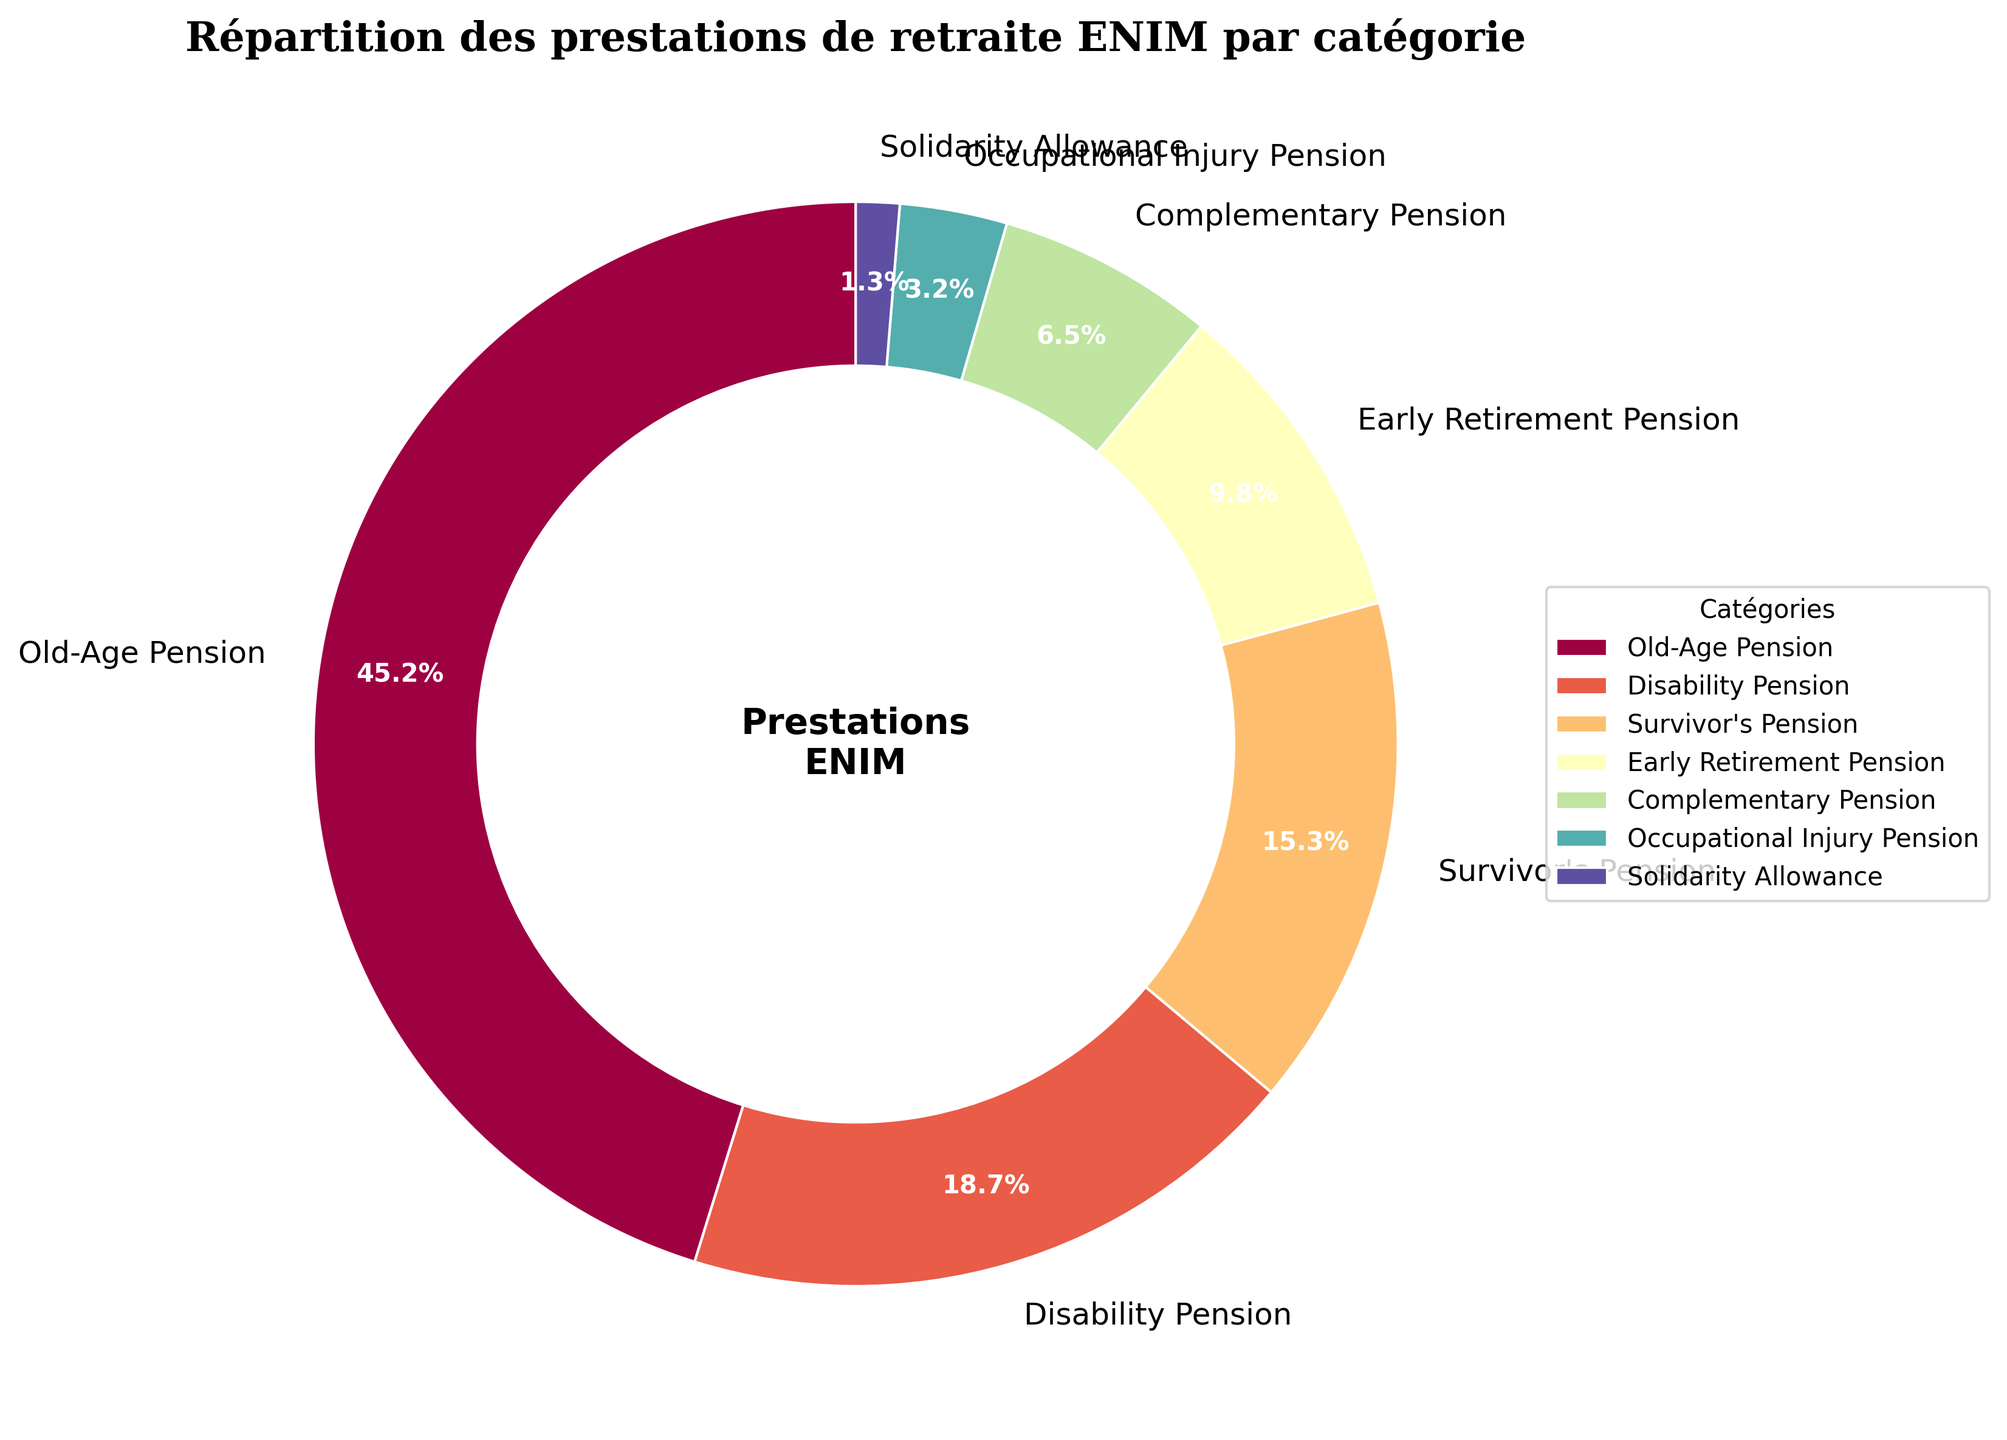What percentage of the total pension benefits is allocated to old-age pensions and survivor's pensions combined? Add the percentage of old-age pensions to the percentage of survivor's pensions: 45.2% + 15.3% = 60.5%
Answer: 60.5% Which pension category receives the least amount of benefits? Look for the smallest percentage in the pie chart, which is the solidarity allowance at 1.3%.
Answer: Solidarity Allowance Are the disability pension and the early retirement pension combined more or less than the old-age pension? Add the percentages of disability pension and early retirement pension: 18.7% + 9.8% = 28.5%. Compare this with the old-age pension which is 45.2%. 28.5% is less than 45.2%.
Answer: Less How much greater is the complementary pension compared to the occupational injury pension? Subtract the percentage of the occupational injury pension from the complementary pension: 6.5% - 3.2% = 3.3%
Answer: 3.3% What is the percentage difference between the highest and the lowest categories in the chart? Subtract the smallest percentage (solidarity allowance) from the largest percentage (old-age pension): 45.2% - 1.3% = 43.9%
Answer: 43.9% If the old-age pension benefits were reduced by 10%, what would its new percentage be? Reduce the old-age pension percentage by 10% of its value: 45.2% - (10% of 45.2%) = 45.2% - 4.52% = 40.68%
Answer: 40.68% Which two categories combined make up more than a quarter (25%) of the total benefits? By observation, the disability pension (18.7%) combined with the survivor's pension (15.3%) is more than 25%: 18.7% + 15.3% = 34%.
Answer: Disability and Survivor's pensions What percentage of the total benefits is allocated to pensions other than the old-age pension? Subtract the old-age pension percentage from 100%: 100% - 45.2% = 54.8%
Answer: 54.8% How many categories in the chart have less than 10% allocation of benefits each? Count the categories with percentages less than 10%: early retirement pension, complementary pension, occupational injury pension, and solidarity allowance. There are 4 such categories.
Answer: 4 Which category in the pie chart is represented by the largest wedge? Identify the largest section in the pie chart, which corresponds to the old-age pension with 45.2%.
Answer: Old-Age Pension 